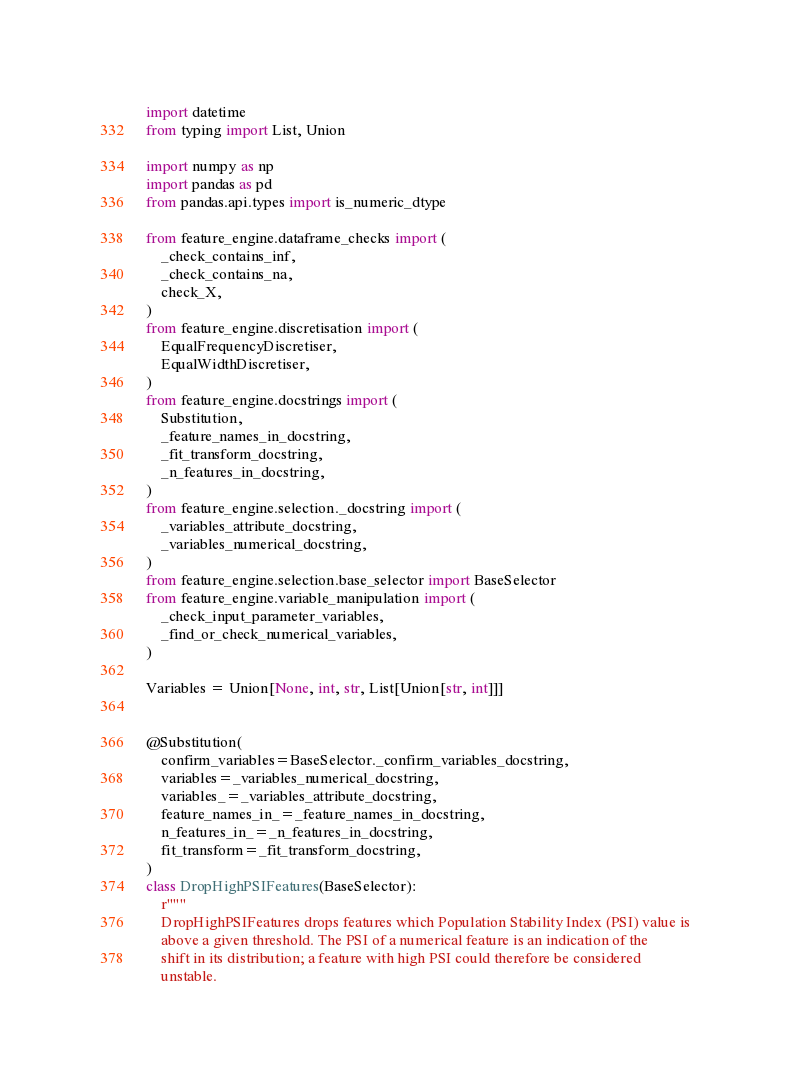<code> <loc_0><loc_0><loc_500><loc_500><_Python_>import datetime
from typing import List, Union

import numpy as np
import pandas as pd
from pandas.api.types import is_numeric_dtype

from feature_engine.dataframe_checks import (
    _check_contains_inf,
    _check_contains_na,
    check_X,
)
from feature_engine.discretisation import (
    EqualFrequencyDiscretiser,
    EqualWidthDiscretiser,
)
from feature_engine.docstrings import (
    Substitution,
    _feature_names_in_docstring,
    _fit_transform_docstring,
    _n_features_in_docstring,
)
from feature_engine.selection._docstring import (
    _variables_attribute_docstring,
    _variables_numerical_docstring,
)
from feature_engine.selection.base_selector import BaseSelector
from feature_engine.variable_manipulation import (
    _check_input_parameter_variables,
    _find_or_check_numerical_variables,
)

Variables = Union[None, int, str, List[Union[str, int]]]


@Substitution(
    confirm_variables=BaseSelector._confirm_variables_docstring,
    variables=_variables_numerical_docstring,
    variables_=_variables_attribute_docstring,
    feature_names_in_=_feature_names_in_docstring,
    n_features_in_=_n_features_in_docstring,
    fit_transform=_fit_transform_docstring,
)
class DropHighPSIFeatures(BaseSelector):
    r"""
    DropHighPSIFeatures drops features which Population Stability Index (PSI) value is
    above a given threshold. The PSI of a numerical feature is an indication of the
    shift in its distribution; a feature with high PSI could therefore be considered
    unstable.
</code> 